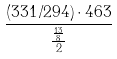<formula> <loc_0><loc_0><loc_500><loc_500>\frac { ( 3 3 1 / 2 9 4 ) \cdot 4 6 3 } { \frac { \frac { 1 3 } { 8 } } { 2 } }</formula> 